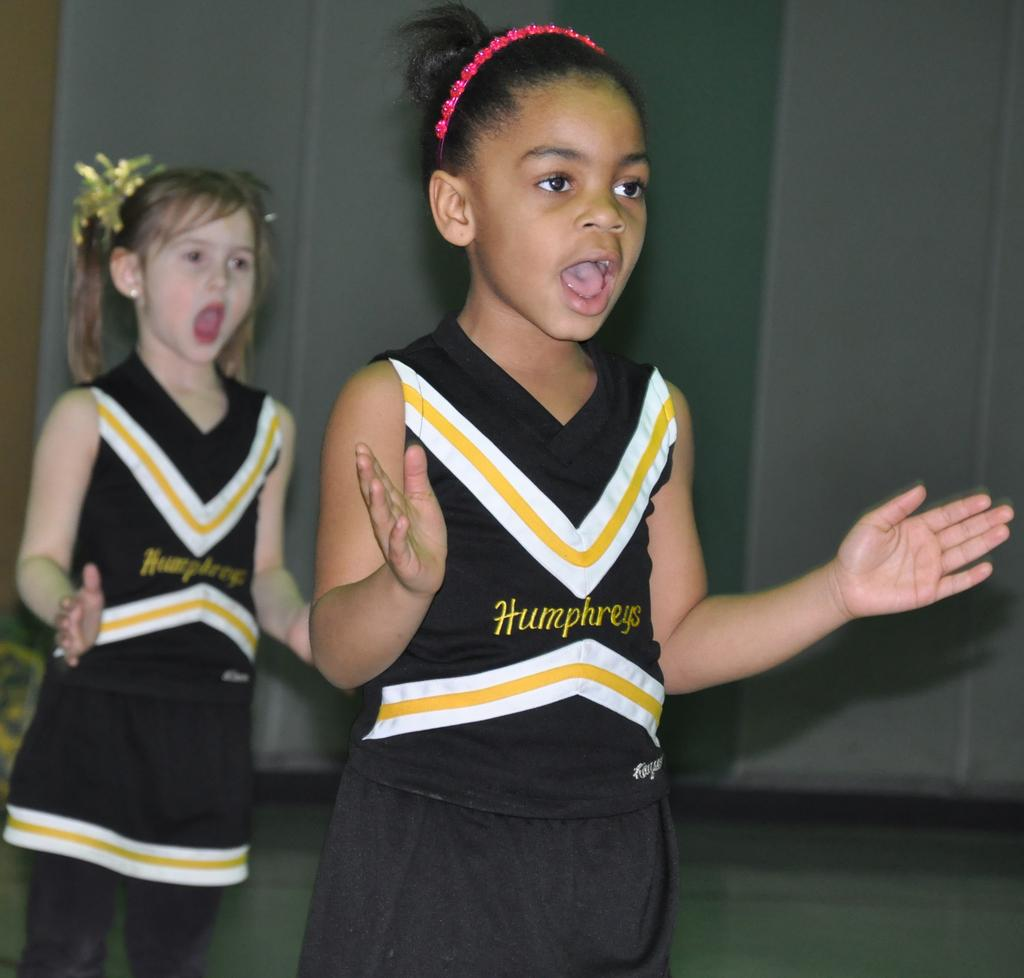Provide a one-sentence caption for the provided image. Two girls dressed in Humphreys cheerleading outfits are doing a routine. 